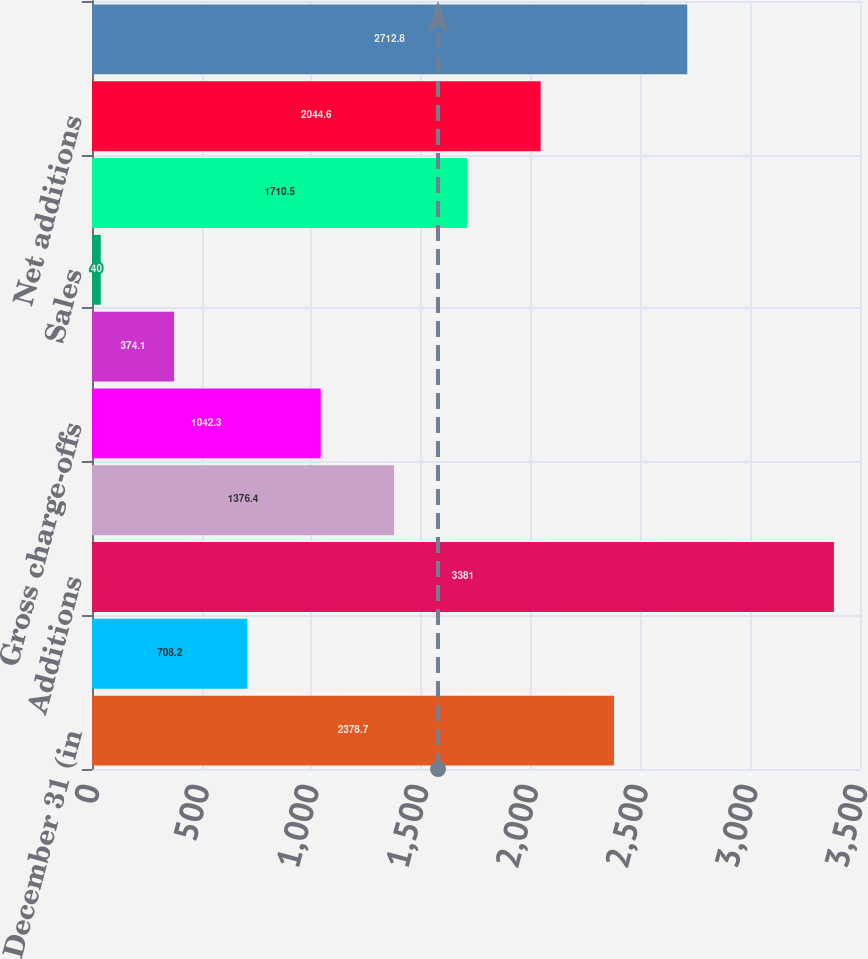<chart> <loc_0><loc_0><loc_500><loc_500><bar_chart><fcel>Year ended December 31 (in<fcel>Beginning balance<fcel>Additions<fcel>Paydowns and other<fcel>Gross charge-offs<fcel>Returned to performing<fcel>Sales<fcel>Total reductions<fcel>Net additions<fcel>Ending balance<nl><fcel>2378.7<fcel>708.2<fcel>3381<fcel>1376.4<fcel>1042.3<fcel>374.1<fcel>40<fcel>1710.5<fcel>2044.6<fcel>2712.8<nl></chart> 